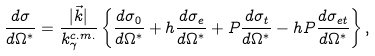<formula> <loc_0><loc_0><loc_500><loc_500>\frac { d \sigma } { d \Omega ^ { * } } = \frac { | \vec { k } | } { k _ { \gamma } ^ { c . m . } } \left \{ \frac { d \sigma _ { 0 } } { d \Omega ^ { * } } + h \frac { d \sigma _ { e } } { d \Omega ^ { * } } + P \frac { d \sigma _ { t } } { d \Omega ^ { * } } - h P \frac { d \sigma _ { e t } } { d \Omega ^ { * } } \right \} ,</formula> 